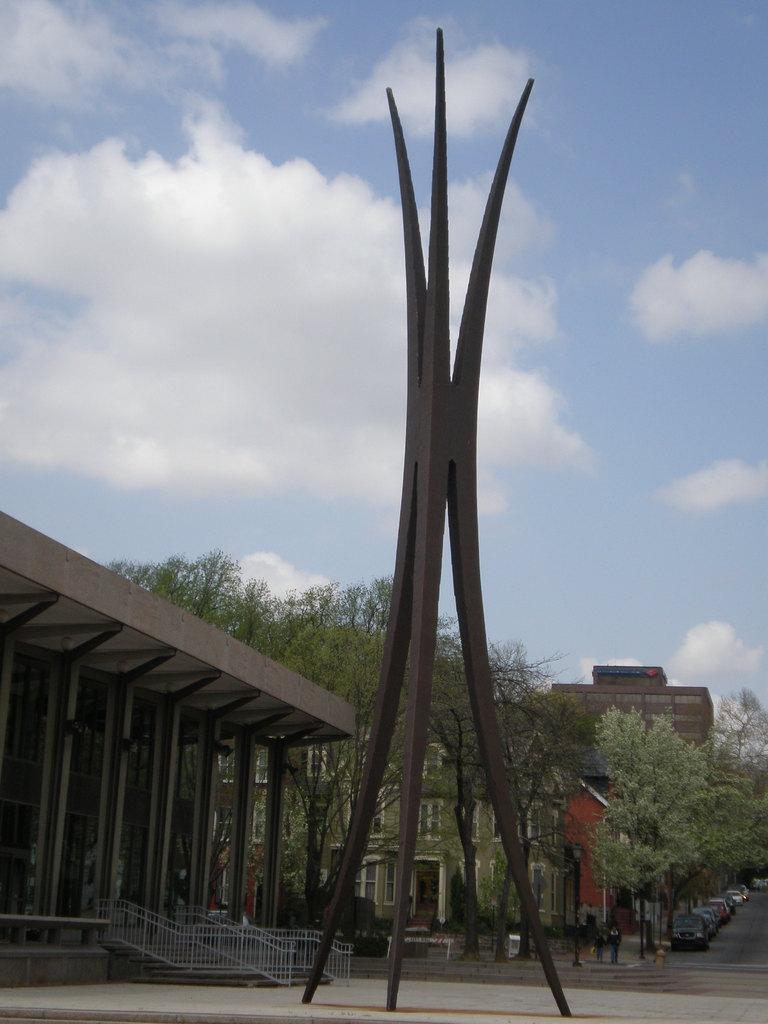Could you give a brief overview of what you see in this image? Here I can see three poles on the road. In the background there are some buildings, trees and few cars on the road. On the top of the image I can see the sky and clouds. 